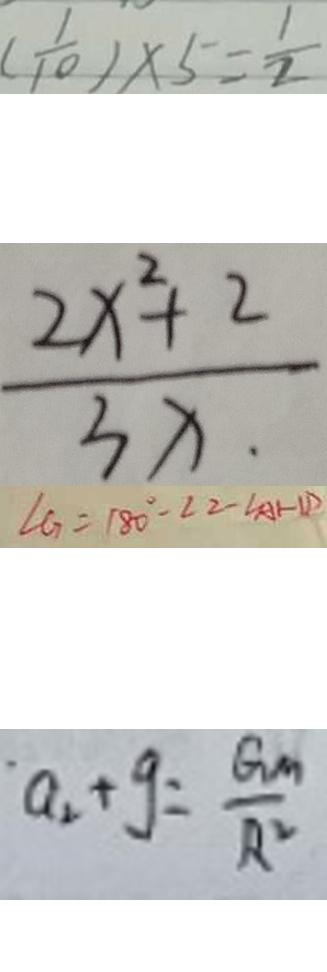Convert formula to latex. <formula><loc_0><loc_0><loc_500><loc_500>( \frac { 1 } { 1 0 } ) \times 5 = \frac { 1 } { 2 } 
 \frac { 2 x ^ { 2 } + 2 } { 3 x } 
 \angle G = 1 8 0 ^ { \circ } - \angle 2 - \angle A H D 
 a _ { 2 } + g = \frac { G m ^ { 2 } } { R ^ { 2 } }</formula> 